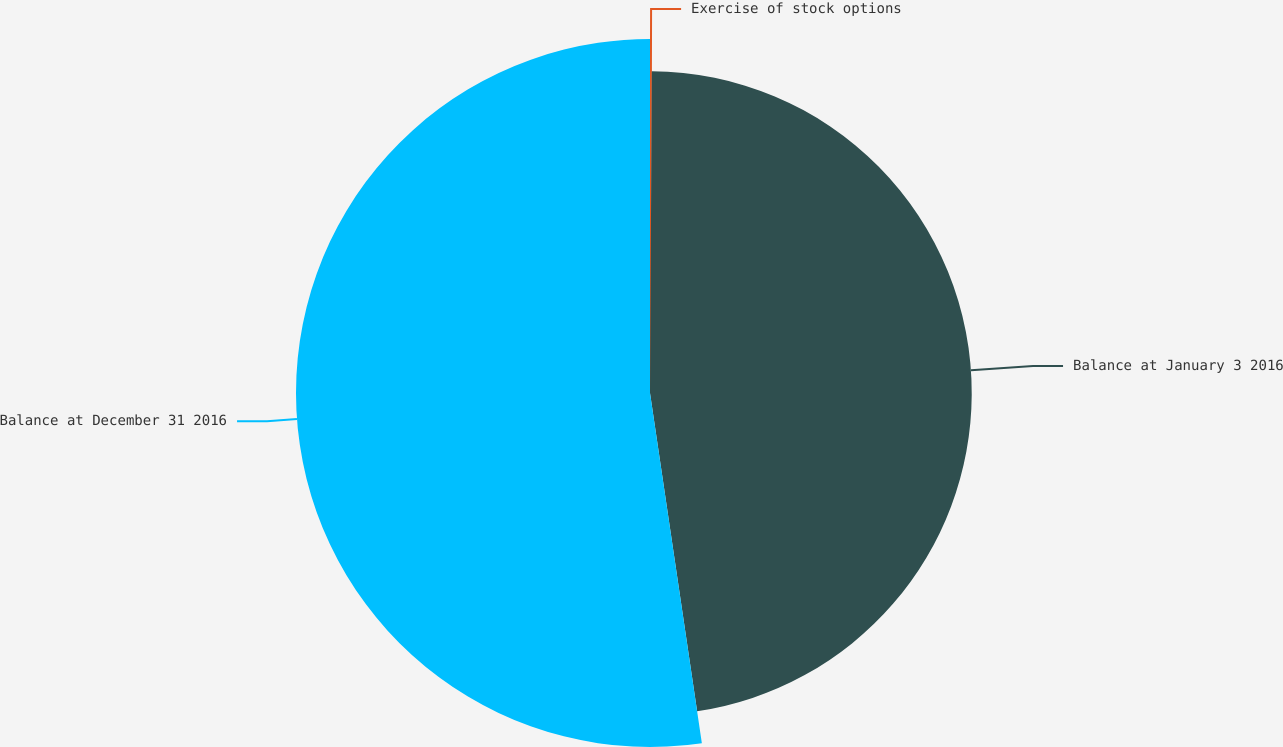Convert chart to OTSL. <chart><loc_0><loc_0><loc_500><loc_500><pie_chart><fcel>Exercise of stock options<fcel>Balance at January 3 2016<fcel>Balance at December 31 2016<nl><fcel>0.09%<fcel>47.57%<fcel>52.34%<nl></chart> 